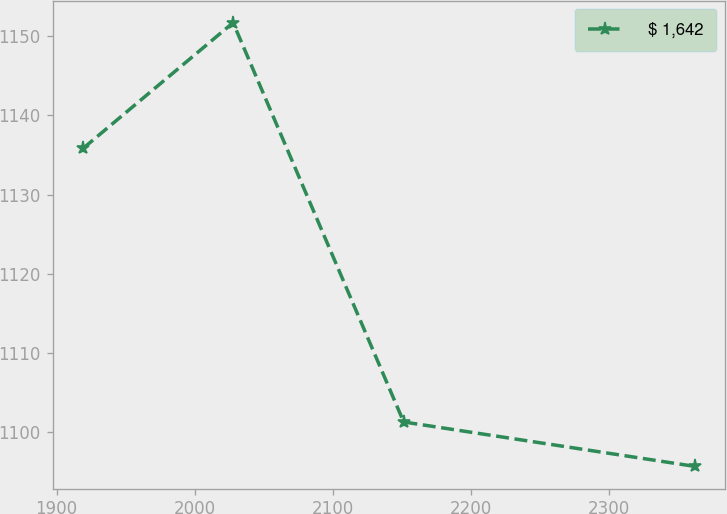<chart> <loc_0><loc_0><loc_500><loc_500><line_chart><ecel><fcel>$ 1,642<nl><fcel>1919.18<fcel>1135.82<nl><fcel>2027.8<fcel>1151.68<nl><fcel>2151.27<fcel>1101.3<nl><fcel>2361.82<fcel>1095.7<nl></chart> 